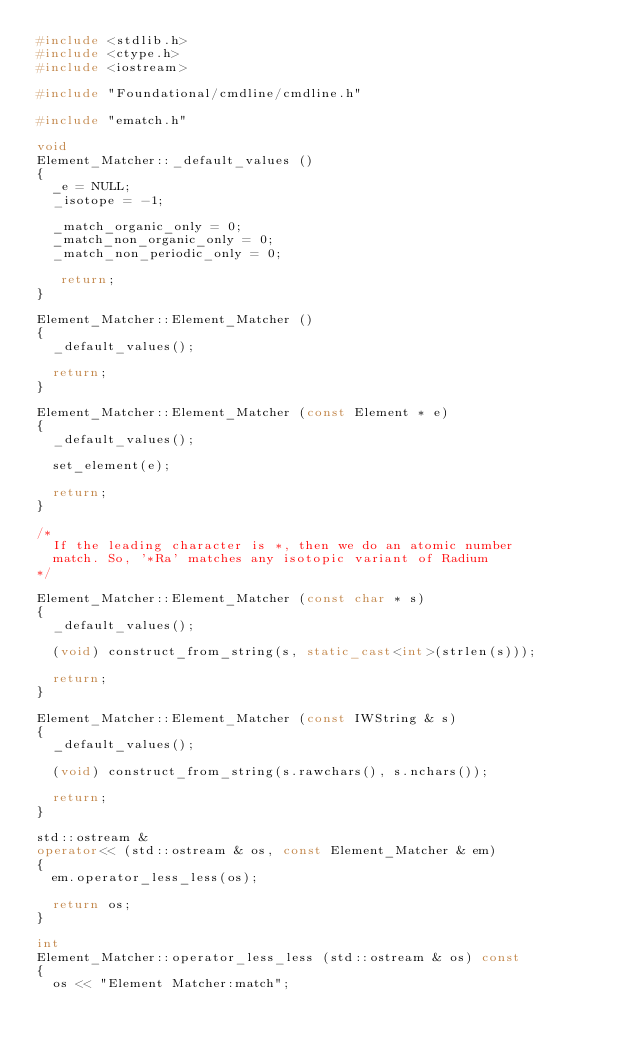Convert code to text. <code><loc_0><loc_0><loc_500><loc_500><_C++_>#include <stdlib.h>
#include <ctype.h>
#include <iostream>

#include "Foundational/cmdline/cmdline.h"

#include "ematch.h"

void
Element_Matcher::_default_values ()
{
  _e = NULL;
  _isotope = -1;

  _match_organic_only = 0;
  _match_non_organic_only = 0;
  _match_non_periodic_only = 0;

   return;
}

Element_Matcher::Element_Matcher ()
{
  _default_values();

  return;
}

Element_Matcher::Element_Matcher (const Element * e)
{
  _default_values();

  set_element(e);

  return;
}

/*
  If the leading character is *, then we do an atomic number
  match. So, '*Ra' matches any isotopic variant of Radium
*/

Element_Matcher::Element_Matcher (const char * s)
{
  _default_values();

  (void) construct_from_string(s, static_cast<int>(strlen(s)));

  return;
}

Element_Matcher::Element_Matcher (const IWString & s)
{
  _default_values();

  (void) construct_from_string(s.rawchars(), s.nchars());

  return;
}

std::ostream &
operator<< (std::ostream & os, const Element_Matcher & em)
{
  em.operator_less_less(os);

  return os;
}

int
Element_Matcher::operator_less_less (std::ostream & os) const
{
  os << "Element Matcher:match";
</code> 